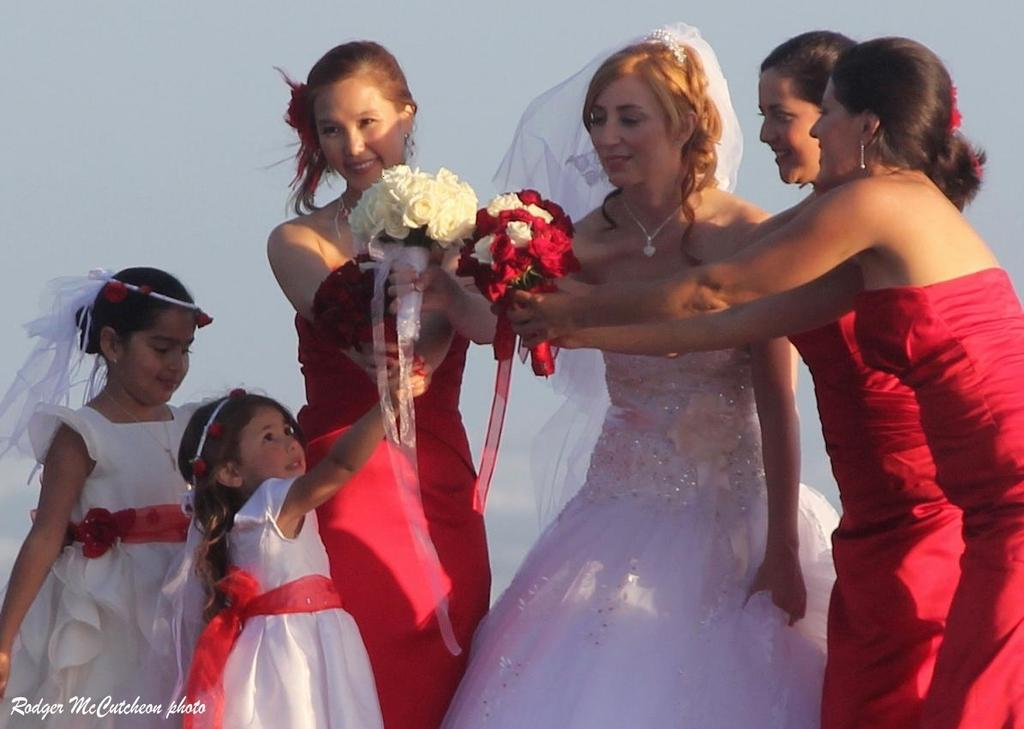What is the main subject of the image? The main subject of the image is the girls in the center. What are the girls holding in their hands? The girls are holding flowers in their hands. Are there any other girls in the image? Yes, there are two small girls on the left side of the image. What type of army uniform can be seen on the girls in the image? There is no army uniform present in the image; the girls are holding flowers. Can you tell me how many kettles are visible in the image? There are no kettles visible in the image. 